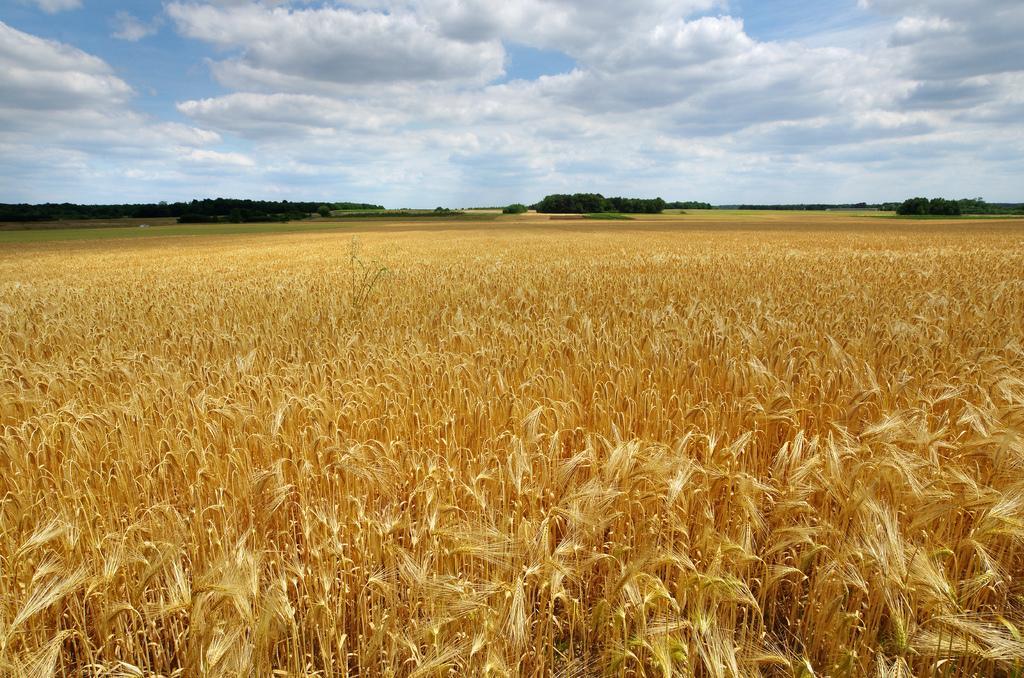Describe this image in one or two sentences. In this image I can see few plants which are brown in color on the ground. In the background I can see few trees which are green in color and the sky. 